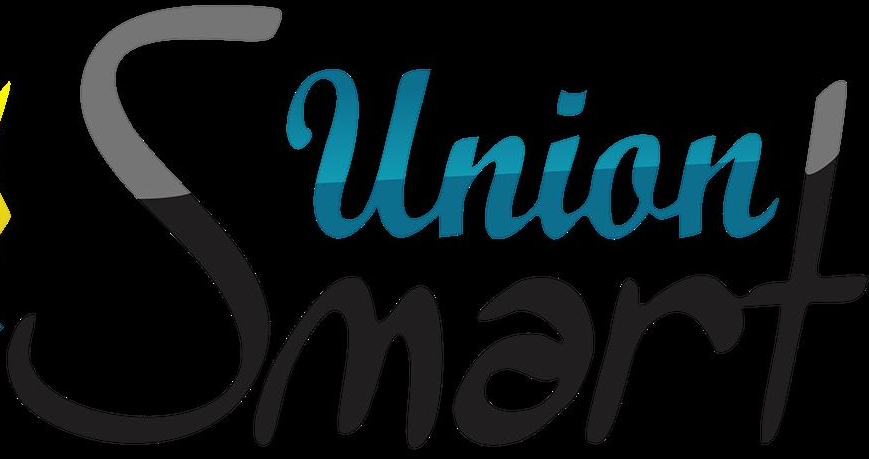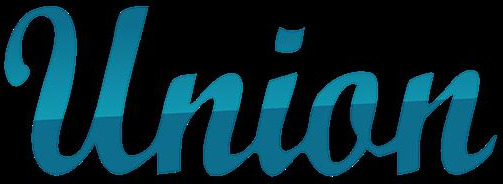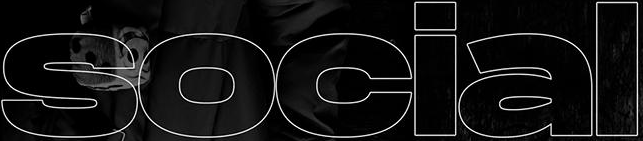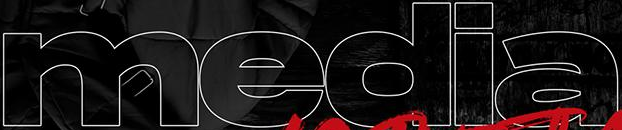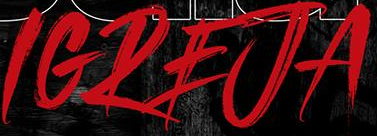Identify the words shown in these images in order, separated by a semicolon. Smart; Union; social; media; IGREJA 